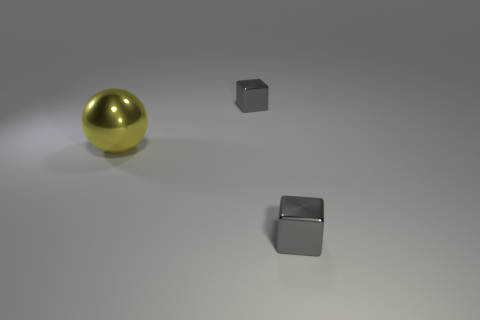Add 2 small gray blocks. How many objects exist? 5 Subtract all spheres. How many objects are left? 2 Add 3 large metallic things. How many large metallic things exist? 4 Subtract 0 blue balls. How many objects are left? 3 Subtract all big purple cubes. Subtract all big objects. How many objects are left? 2 Add 2 yellow metallic things. How many yellow metallic things are left? 3 